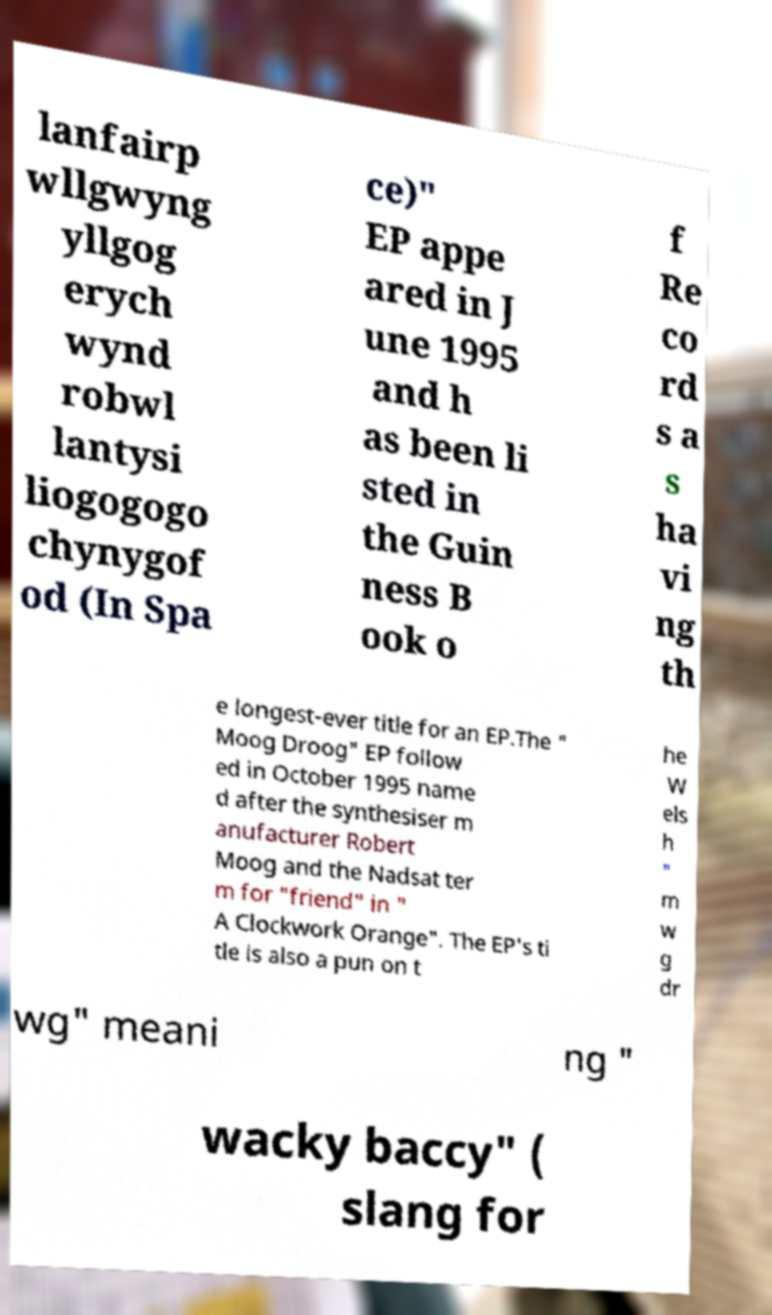Can you read and provide the text displayed in the image?This photo seems to have some interesting text. Can you extract and type it out for me? lanfairp wllgwyng yllgog erych wynd robwl lantysi liogogogo chynygof od (In Spa ce)" EP appe ared in J une 1995 and h as been li sted in the Guin ness B ook o f Re co rd s a s ha vi ng th e longest-ever title for an EP.The " Moog Droog" EP follow ed in October 1995 name d after the synthesiser m anufacturer Robert Moog and the Nadsat ter m for "friend" in " A Clockwork Orange". The EP's ti tle is also a pun on t he W els h " m w g dr wg" meani ng " wacky baccy" ( slang for 